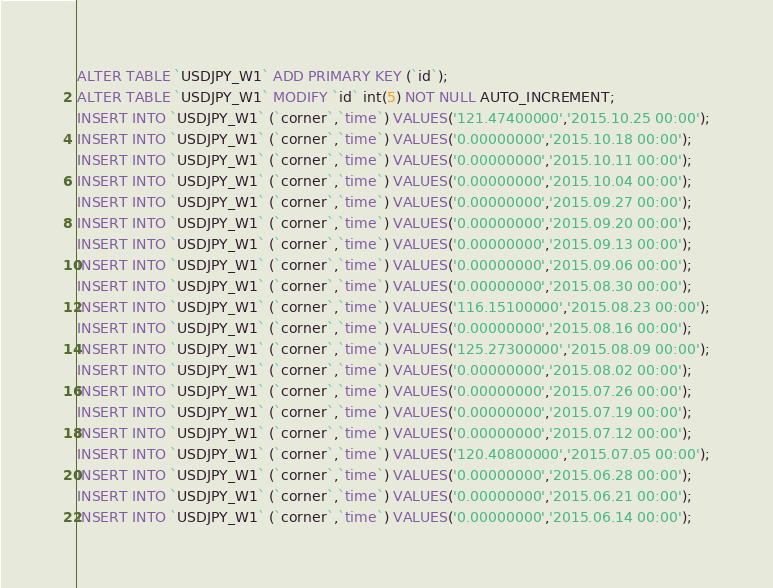<code> <loc_0><loc_0><loc_500><loc_500><_SQL_>ALTER TABLE `USDJPY_W1` ADD PRIMARY KEY (`id`);
ALTER TABLE `USDJPY_W1` MODIFY `id` int(5) NOT NULL AUTO_INCREMENT;
INSERT INTO `USDJPY_W1` (`corner`,`time`) VALUES('121.47400000','2015.10.25 00:00');
INSERT INTO `USDJPY_W1` (`corner`,`time`) VALUES('0.00000000','2015.10.18 00:00');
INSERT INTO `USDJPY_W1` (`corner`,`time`) VALUES('0.00000000','2015.10.11 00:00');
INSERT INTO `USDJPY_W1` (`corner`,`time`) VALUES('0.00000000','2015.10.04 00:00');
INSERT INTO `USDJPY_W1` (`corner`,`time`) VALUES('0.00000000','2015.09.27 00:00');
INSERT INTO `USDJPY_W1` (`corner`,`time`) VALUES('0.00000000','2015.09.20 00:00');
INSERT INTO `USDJPY_W1` (`corner`,`time`) VALUES('0.00000000','2015.09.13 00:00');
INSERT INTO `USDJPY_W1` (`corner`,`time`) VALUES('0.00000000','2015.09.06 00:00');
INSERT INTO `USDJPY_W1` (`corner`,`time`) VALUES('0.00000000','2015.08.30 00:00');
INSERT INTO `USDJPY_W1` (`corner`,`time`) VALUES('116.15100000','2015.08.23 00:00');
INSERT INTO `USDJPY_W1` (`corner`,`time`) VALUES('0.00000000','2015.08.16 00:00');
INSERT INTO `USDJPY_W1` (`corner`,`time`) VALUES('125.27300000','2015.08.09 00:00');
INSERT INTO `USDJPY_W1` (`corner`,`time`) VALUES('0.00000000','2015.08.02 00:00');
INSERT INTO `USDJPY_W1` (`corner`,`time`) VALUES('0.00000000','2015.07.26 00:00');
INSERT INTO `USDJPY_W1` (`corner`,`time`) VALUES('0.00000000','2015.07.19 00:00');
INSERT INTO `USDJPY_W1` (`corner`,`time`) VALUES('0.00000000','2015.07.12 00:00');
INSERT INTO `USDJPY_W1` (`corner`,`time`) VALUES('120.40800000','2015.07.05 00:00');
INSERT INTO `USDJPY_W1` (`corner`,`time`) VALUES('0.00000000','2015.06.28 00:00');
INSERT INTO `USDJPY_W1` (`corner`,`time`) VALUES('0.00000000','2015.06.21 00:00');
INSERT INTO `USDJPY_W1` (`corner`,`time`) VALUES('0.00000000','2015.06.14 00:00');</code> 